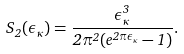<formula> <loc_0><loc_0><loc_500><loc_500>S _ { 2 } ( \epsilon _ { \kappa } ) = \frac { \epsilon _ { \kappa } ^ { 3 } } { 2 \pi ^ { 2 } ( e ^ { 2 \pi \epsilon _ { \kappa } } - 1 ) } .</formula> 